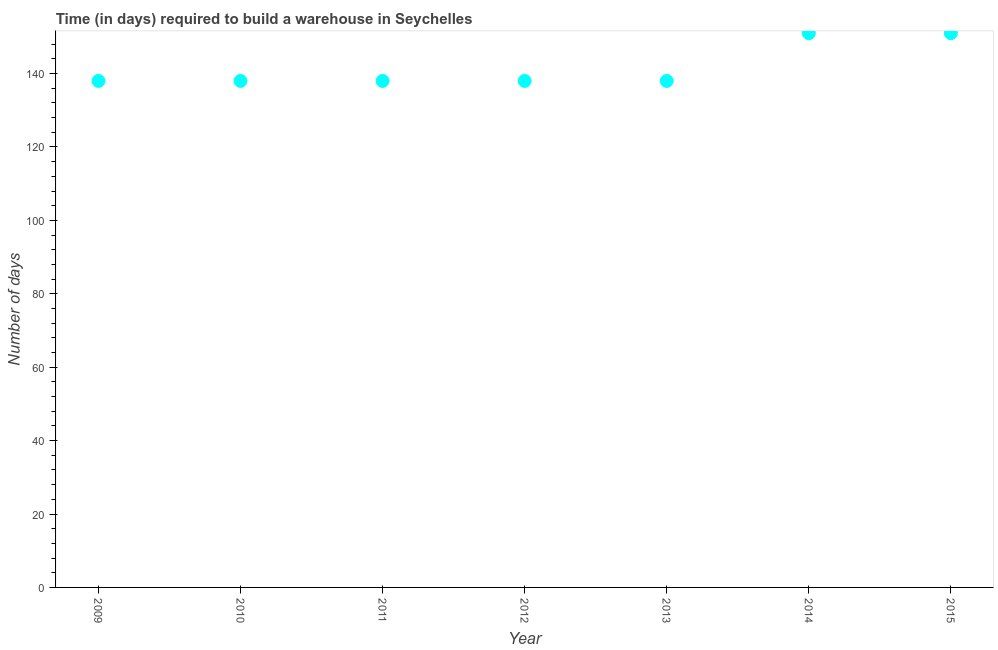What is the time required to build a warehouse in 2012?
Keep it short and to the point. 138. Across all years, what is the maximum time required to build a warehouse?
Give a very brief answer. 151. Across all years, what is the minimum time required to build a warehouse?
Provide a succinct answer. 138. In which year was the time required to build a warehouse minimum?
Provide a succinct answer. 2009. What is the sum of the time required to build a warehouse?
Provide a succinct answer. 992. What is the difference between the time required to build a warehouse in 2010 and 2015?
Make the answer very short. -13. What is the average time required to build a warehouse per year?
Offer a terse response. 141.71. What is the median time required to build a warehouse?
Keep it short and to the point. 138. In how many years, is the time required to build a warehouse greater than 64 days?
Your answer should be compact. 7. What is the ratio of the time required to build a warehouse in 2014 to that in 2015?
Ensure brevity in your answer.  1. Is the time required to build a warehouse in 2009 less than that in 2013?
Offer a terse response. No. What is the difference between the highest and the second highest time required to build a warehouse?
Ensure brevity in your answer.  0. Is the sum of the time required to build a warehouse in 2014 and 2015 greater than the maximum time required to build a warehouse across all years?
Provide a short and direct response. Yes. What is the difference between the highest and the lowest time required to build a warehouse?
Offer a terse response. 13. Does the time required to build a warehouse monotonically increase over the years?
Your response must be concise. No. How many dotlines are there?
Give a very brief answer. 1. How many years are there in the graph?
Provide a succinct answer. 7. Does the graph contain any zero values?
Give a very brief answer. No. What is the title of the graph?
Provide a succinct answer. Time (in days) required to build a warehouse in Seychelles. What is the label or title of the X-axis?
Provide a short and direct response. Year. What is the label or title of the Y-axis?
Offer a terse response. Number of days. What is the Number of days in 2009?
Your answer should be very brief. 138. What is the Number of days in 2010?
Offer a terse response. 138. What is the Number of days in 2011?
Offer a very short reply. 138. What is the Number of days in 2012?
Your answer should be compact. 138. What is the Number of days in 2013?
Ensure brevity in your answer.  138. What is the Number of days in 2014?
Offer a very short reply. 151. What is the Number of days in 2015?
Give a very brief answer. 151. What is the difference between the Number of days in 2009 and 2010?
Offer a very short reply. 0. What is the difference between the Number of days in 2009 and 2012?
Provide a succinct answer. 0. What is the difference between the Number of days in 2009 and 2013?
Provide a short and direct response. 0. What is the difference between the Number of days in 2010 and 2012?
Ensure brevity in your answer.  0. What is the difference between the Number of days in 2010 and 2015?
Provide a succinct answer. -13. What is the difference between the Number of days in 2011 and 2013?
Make the answer very short. 0. What is the difference between the Number of days in 2012 and 2013?
Provide a short and direct response. 0. What is the difference between the Number of days in 2014 and 2015?
Your response must be concise. 0. What is the ratio of the Number of days in 2009 to that in 2010?
Offer a very short reply. 1. What is the ratio of the Number of days in 2009 to that in 2012?
Offer a terse response. 1. What is the ratio of the Number of days in 2009 to that in 2013?
Give a very brief answer. 1. What is the ratio of the Number of days in 2009 to that in 2014?
Offer a very short reply. 0.91. What is the ratio of the Number of days in 2009 to that in 2015?
Offer a terse response. 0.91. What is the ratio of the Number of days in 2010 to that in 2012?
Provide a succinct answer. 1. What is the ratio of the Number of days in 2010 to that in 2013?
Your response must be concise. 1. What is the ratio of the Number of days in 2010 to that in 2014?
Offer a very short reply. 0.91. What is the ratio of the Number of days in 2010 to that in 2015?
Offer a terse response. 0.91. What is the ratio of the Number of days in 2011 to that in 2012?
Provide a short and direct response. 1. What is the ratio of the Number of days in 2011 to that in 2013?
Provide a short and direct response. 1. What is the ratio of the Number of days in 2011 to that in 2014?
Provide a succinct answer. 0.91. What is the ratio of the Number of days in 2011 to that in 2015?
Offer a terse response. 0.91. What is the ratio of the Number of days in 2012 to that in 2014?
Your answer should be compact. 0.91. What is the ratio of the Number of days in 2012 to that in 2015?
Give a very brief answer. 0.91. What is the ratio of the Number of days in 2013 to that in 2014?
Provide a short and direct response. 0.91. What is the ratio of the Number of days in 2013 to that in 2015?
Give a very brief answer. 0.91. What is the ratio of the Number of days in 2014 to that in 2015?
Offer a terse response. 1. 